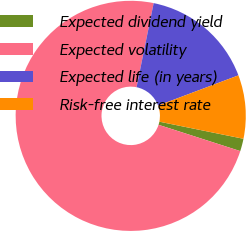Convert chart to OTSL. <chart><loc_0><loc_0><loc_500><loc_500><pie_chart><fcel>Expected dividend yield<fcel>Expected volatility<fcel>Expected life (in years)<fcel>Risk-free interest rate<nl><fcel>1.76%<fcel>73.25%<fcel>16.08%<fcel>8.92%<nl></chart> 